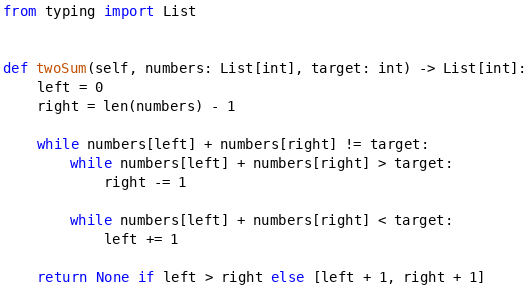<code> <loc_0><loc_0><loc_500><loc_500><_Python_>from typing import List


def twoSum(self, numbers: List[int], target: int) -> List[int]:
    left = 0
    right = len(numbers) - 1

    while numbers[left] + numbers[right] != target:
        while numbers[left] + numbers[right] > target:
            right -= 1

        while numbers[left] + numbers[right] < target:
            left += 1

    return None if left > right else [left + 1, right + 1]
</code> 